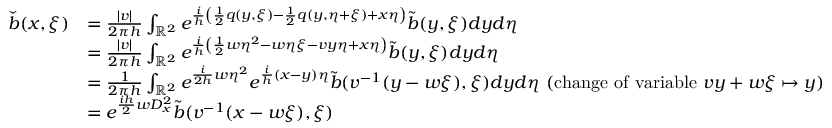Convert formula to latex. <formula><loc_0><loc_0><loc_500><loc_500>\begin{array} { r l } { \check { b } ( x , \xi ) } & { = \frac { | v | } { 2 \pi h } \int _ { \mathbb { R } ^ { 2 } } e ^ { \frac { i } { h } \left ( \frac { 1 } { 2 } q ( y , \xi ) - \frac { 1 } { 2 } q ( y , \eta + \xi ) + x \eta \right ) } \tilde { b } ( y , \xi ) d y d \eta } \\ & { = \frac { | v | } { 2 \pi h } \int _ { \mathbb { R } ^ { 2 } } e ^ { \frac { i } { h } \left ( \frac { 1 } { 2 } w \eta ^ { 2 } - w \eta \xi - v y \eta + x \eta \right ) } \tilde { b } ( y , \xi ) d y d \eta } \\ & { = \frac { 1 } { 2 \pi h } \int _ { \mathbb { R } ^ { 2 } } e ^ { \frac { i } { 2 h } w \eta ^ { 2 } } e ^ { \frac { i } { h } ( x - y ) \eta } \tilde { b } ( v ^ { - 1 } ( y - w \xi ) , \xi ) d y d \eta ( \mathrm { c h a n g e o f v a r i a b l e } v y + w \xi \mapsto y ) } \\ & { = e ^ { \frac { i h } { 2 } w D _ { x } ^ { 2 } } \tilde { b } ( v ^ { - 1 } ( x - w \xi ) , \xi ) } \end{array}</formula> 